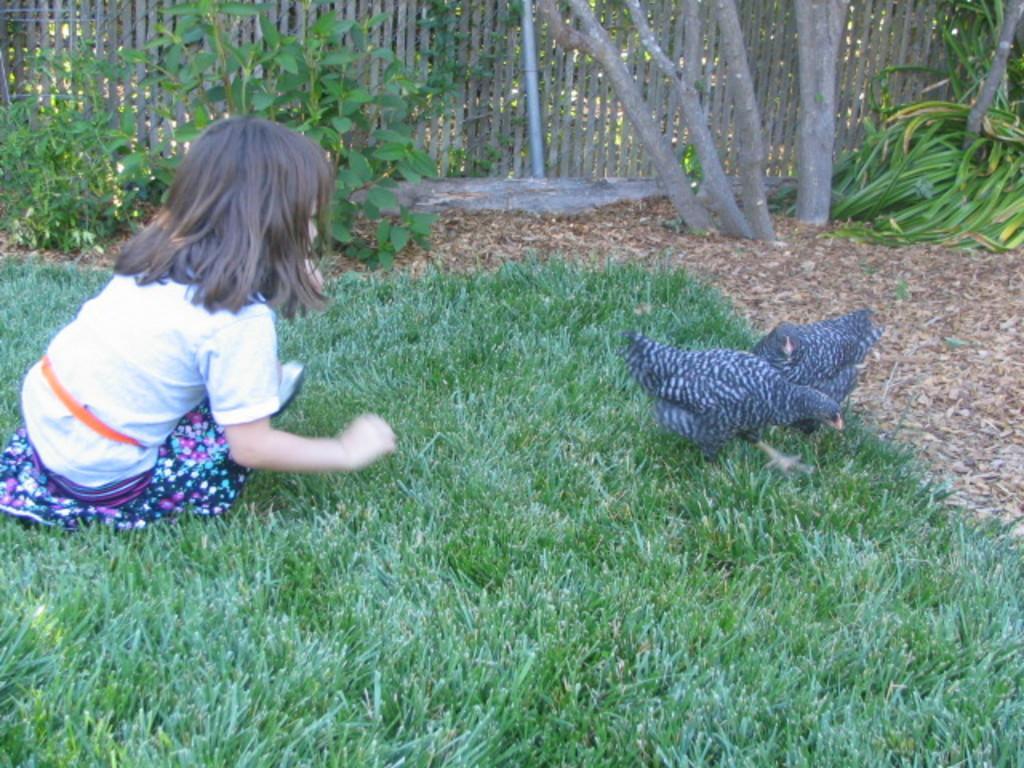Could you give a brief overview of what you see in this image? In this image we can see a kid wearing white color dress and multi color bottom crouching on ground which has some grass, there are some hens which are black in color on right side and in the background of the image there are some plants, trees and fencing. 